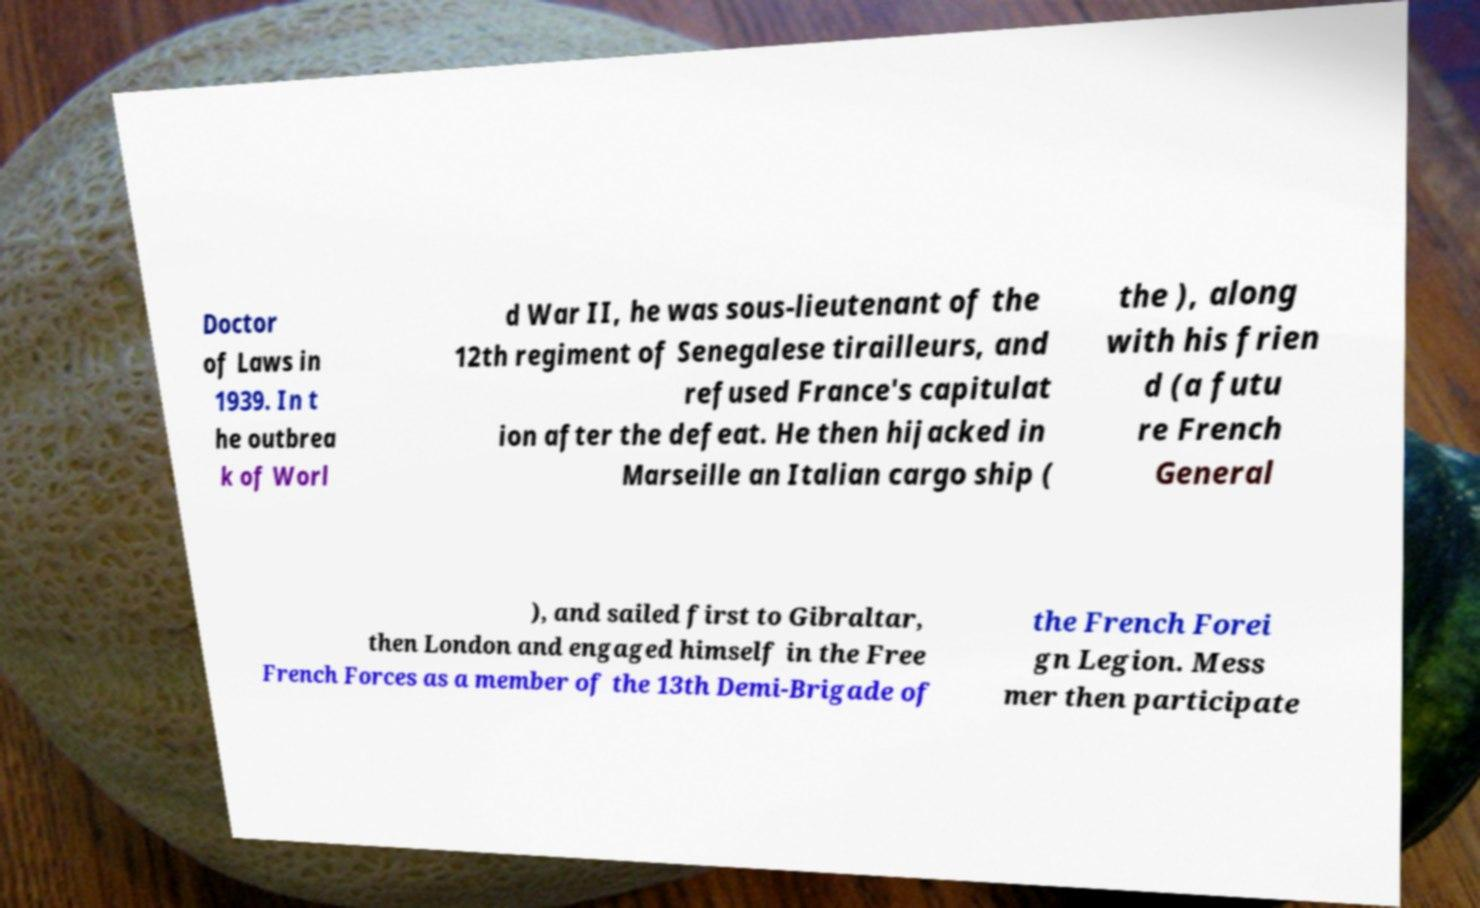Can you read and provide the text displayed in the image?This photo seems to have some interesting text. Can you extract and type it out for me? Doctor of Laws in 1939. In t he outbrea k of Worl d War II, he was sous-lieutenant of the 12th regiment of Senegalese tirailleurs, and refused France's capitulat ion after the defeat. He then hijacked in Marseille an Italian cargo ship ( the ), along with his frien d (a futu re French General ), and sailed first to Gibraltar, then London and engaged himself in the Free French Forces as a member of the 13th Demi-Brigade of the French Forei gn Legion. Mess mer then participate 